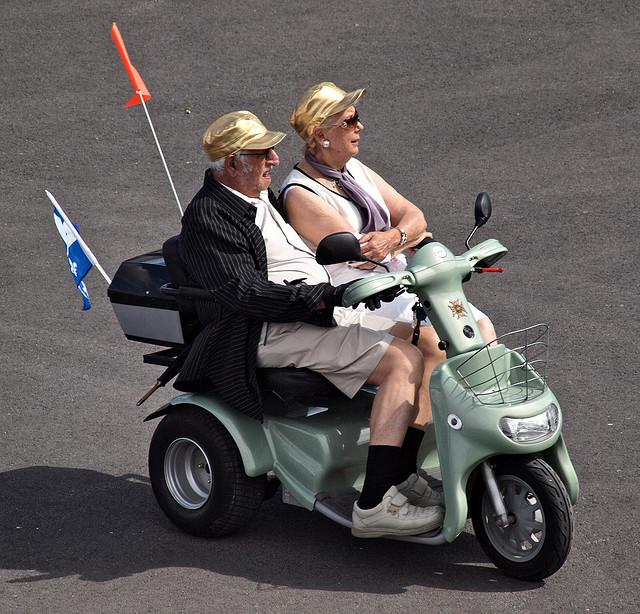Why are two of them on that little vehicle? Please explain your reasoning. economical transportation. The women are sharing the vehicle which is more economical. 